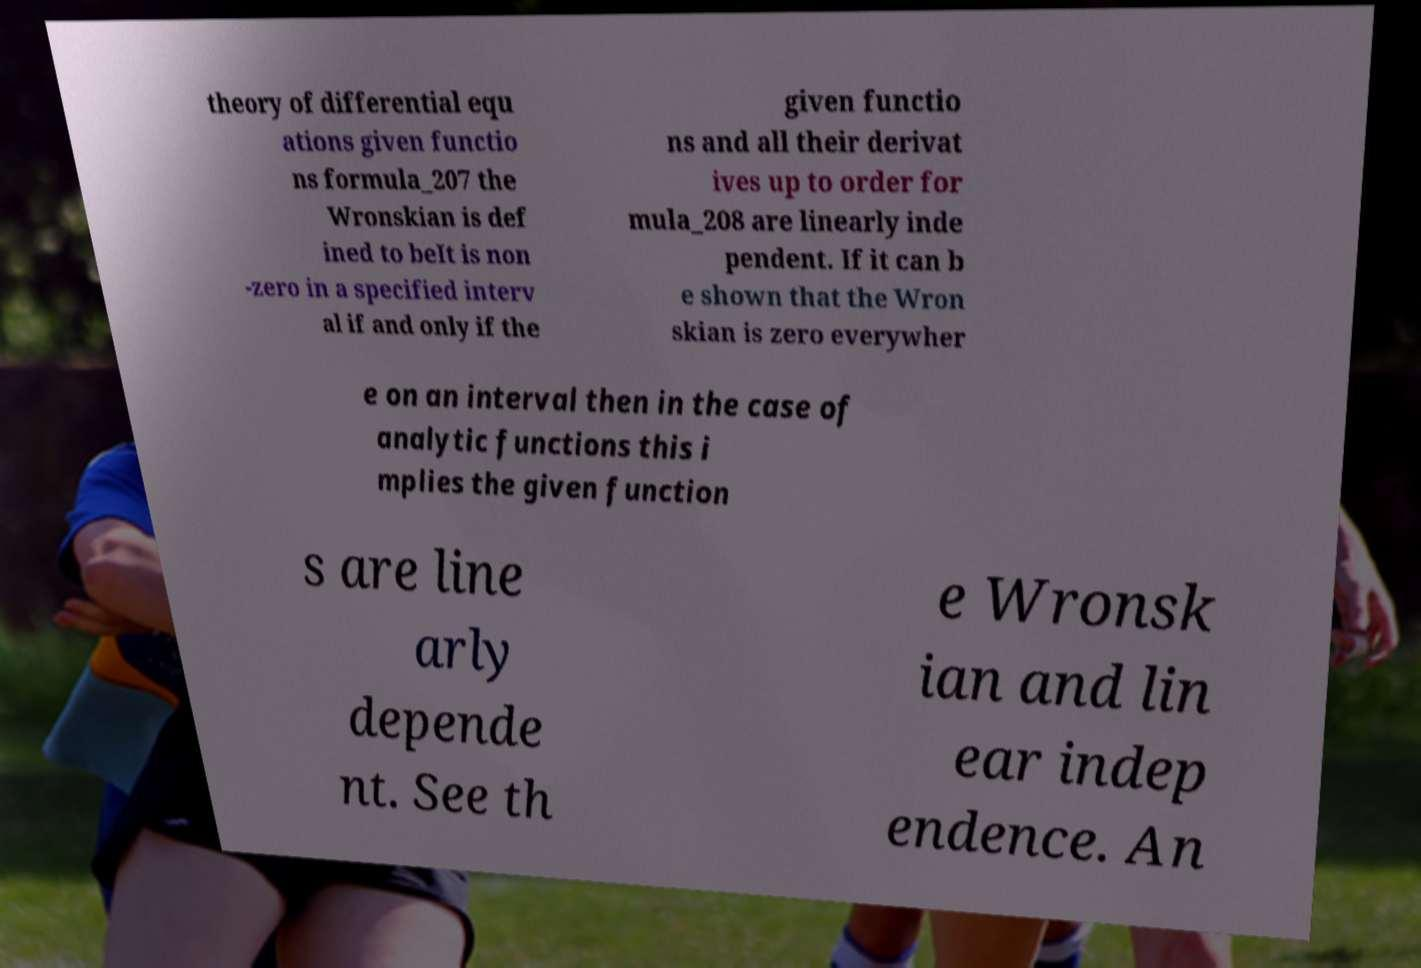What messages or text are displayed in this image? I need them in a readable, typed format. theory of differential equ ations given functio ns formula_207 the Wronskian is def ined to beIt is non -zero in a specified interv al if and only if the given functio ns and all their derivat ives up to order for mula_208 are linearly inde pendent. If it can b e shown that the Wron skian is zero everywher e on an interval then in the case of analytic functions this i mplies the given function s are line arly depende nt. See th e Wronsk ian and lin ear indep endence. An 